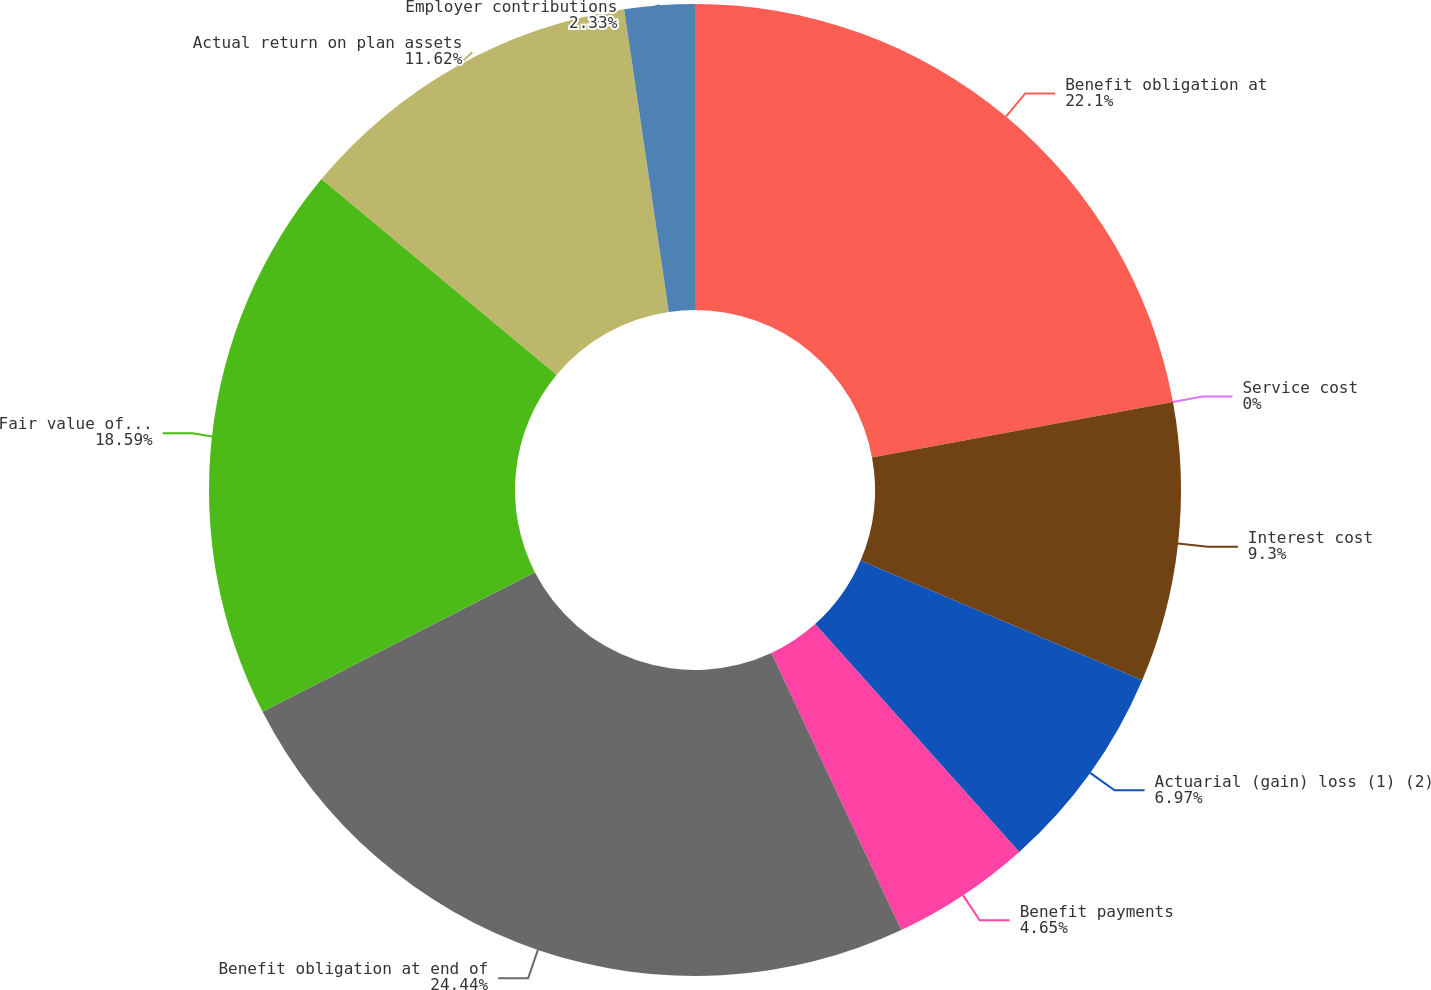Convert chart to OTSL. <chart><loc_0><loc_0><loc_500><loc_500><pie_chart><fcel>Benefit obligation at<fcel>Service cost<fcel>Interest cost<fcel>Actuarial (gain) loss (1) (2)<fcel>Benefit payments<fcel>Benefit obligation at end of<fcel>Fair value of plan assets at<fcel>Actual return on plan assets<fcel>Employer contributions<nl><fcel>22.1%<fcel>0.0%<fcel>9.3%<fcel>6.97%<fcel>4.65%<fcel>24.43%<fcel>18.59%<fcel>11.62%<fcel>2.33%<nl></chart> 